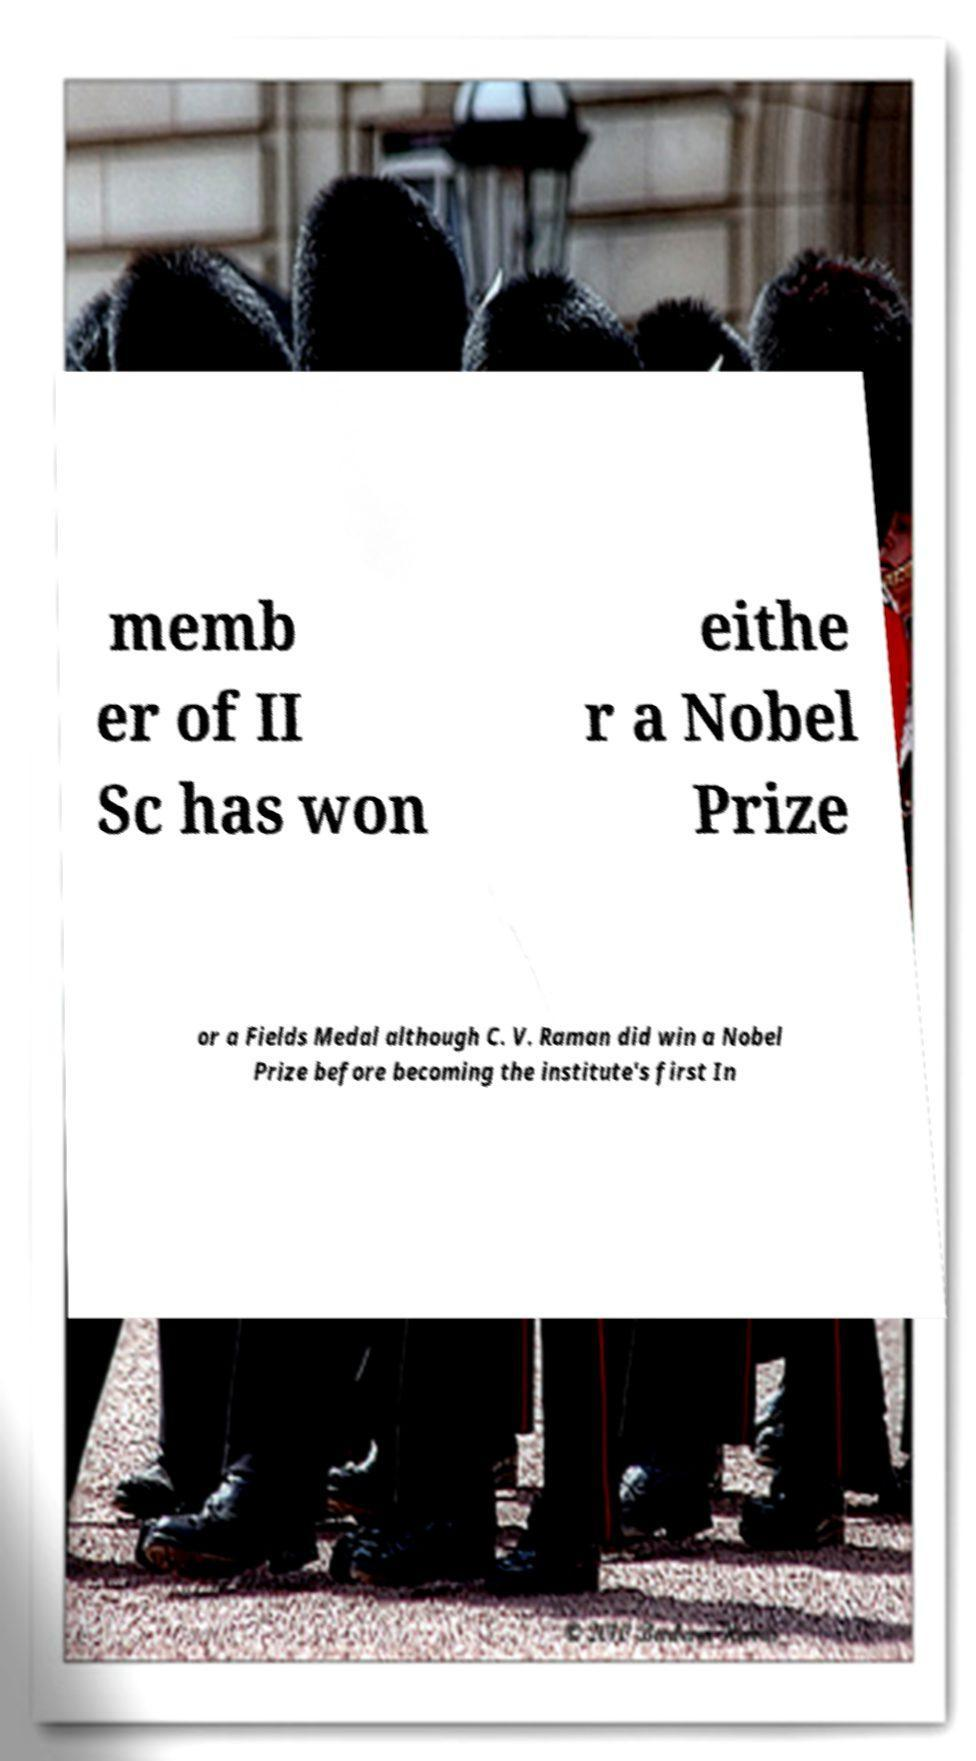Could you extract and type out the text from this image? memb er of II Sc has won eithe r a Nobel Prize or a Fields Medal although C. V. Raman did win a Nobel Prize before becoming the institute's first In 